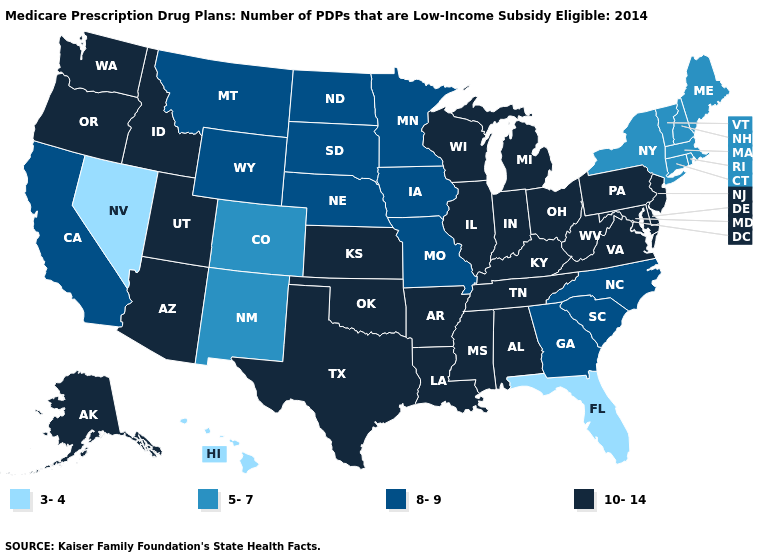Which states have the lowest value in the USA?
Concise answer only. Florida, Hawaii, Nevada. What is the lowest value in the USA?
Write a very short answer. 3-4. What is the lowest value in the USA?
Write a very short answer. 3-4. Does Oregon have the lowest value in the USA?
Be succinct. No. Is the legend a continuous bar?
Quick response, please. No. What is the value of Tennessee?
Give a very brief answer. 10-14. What is the highest value in the USA?
Quick response, please. 10-14. Name the states that have a value in the range 5-7?
Answer briefly. Colorado, Connecticut, Massachusetts, Maine, New Hampshire, New Mexico, New York, Rhode Island, Vermont. Does North Carolina have the lowest value in the USA?
Concise answer only. No. What is the value of California?
Keep it brief. 8-9. Name the states that have a value in the range 10-14?
Short answer required. Alaska, Alabama, Arkansas, Arizona, Delaware, Idaho, Illinois, Indiana, Kansas, Kentucky, Louisiana, Maryland, Michigan, Mississippi, New Jersey, Ohio, Oklahoma, Oregon, Pennsylvania, Tennessee, Texas, Utah, Virginia, Washington, Wisconsin, West Virginia. What is the lowest value in states that border Rhode Island?
Answer briefly. 5-7. What is the value of Arkansas?
Write a very short answer. 10-14. What is the value of Maine?
Be succinct. 5-7. Which states have the lowest value in the Northeast?
Give a very brief answer. Connecticut, Massachusetts, Maine, New Hampshire, New York, Rhode Island, Vermont. 